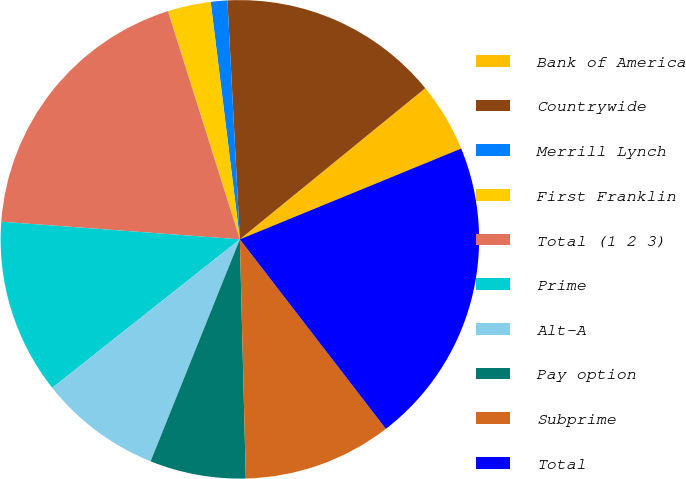Convert chart to OTSL. <chart><loc_0><loc_0><loc_500><loc_500><pie_chart><fcel>Bank of America<fcel>Countrywide<fcel>Merrill Lynch<fcel>First Franklin<fcel>Total (1 2 3)<fcel>Prime<fcel>Alt-A<fcel>Pay option<fcel>Subprime<fcel>Total<nl><fcel>4.69%<fcel>14.94%<fcel>1.12%<fcel>2.91%<fcel>18.97%<fcel>11.83%<fcel>8.26%<fcel>6.48%<fcel>10.05%<fcel>20.75%<nl></chart> 